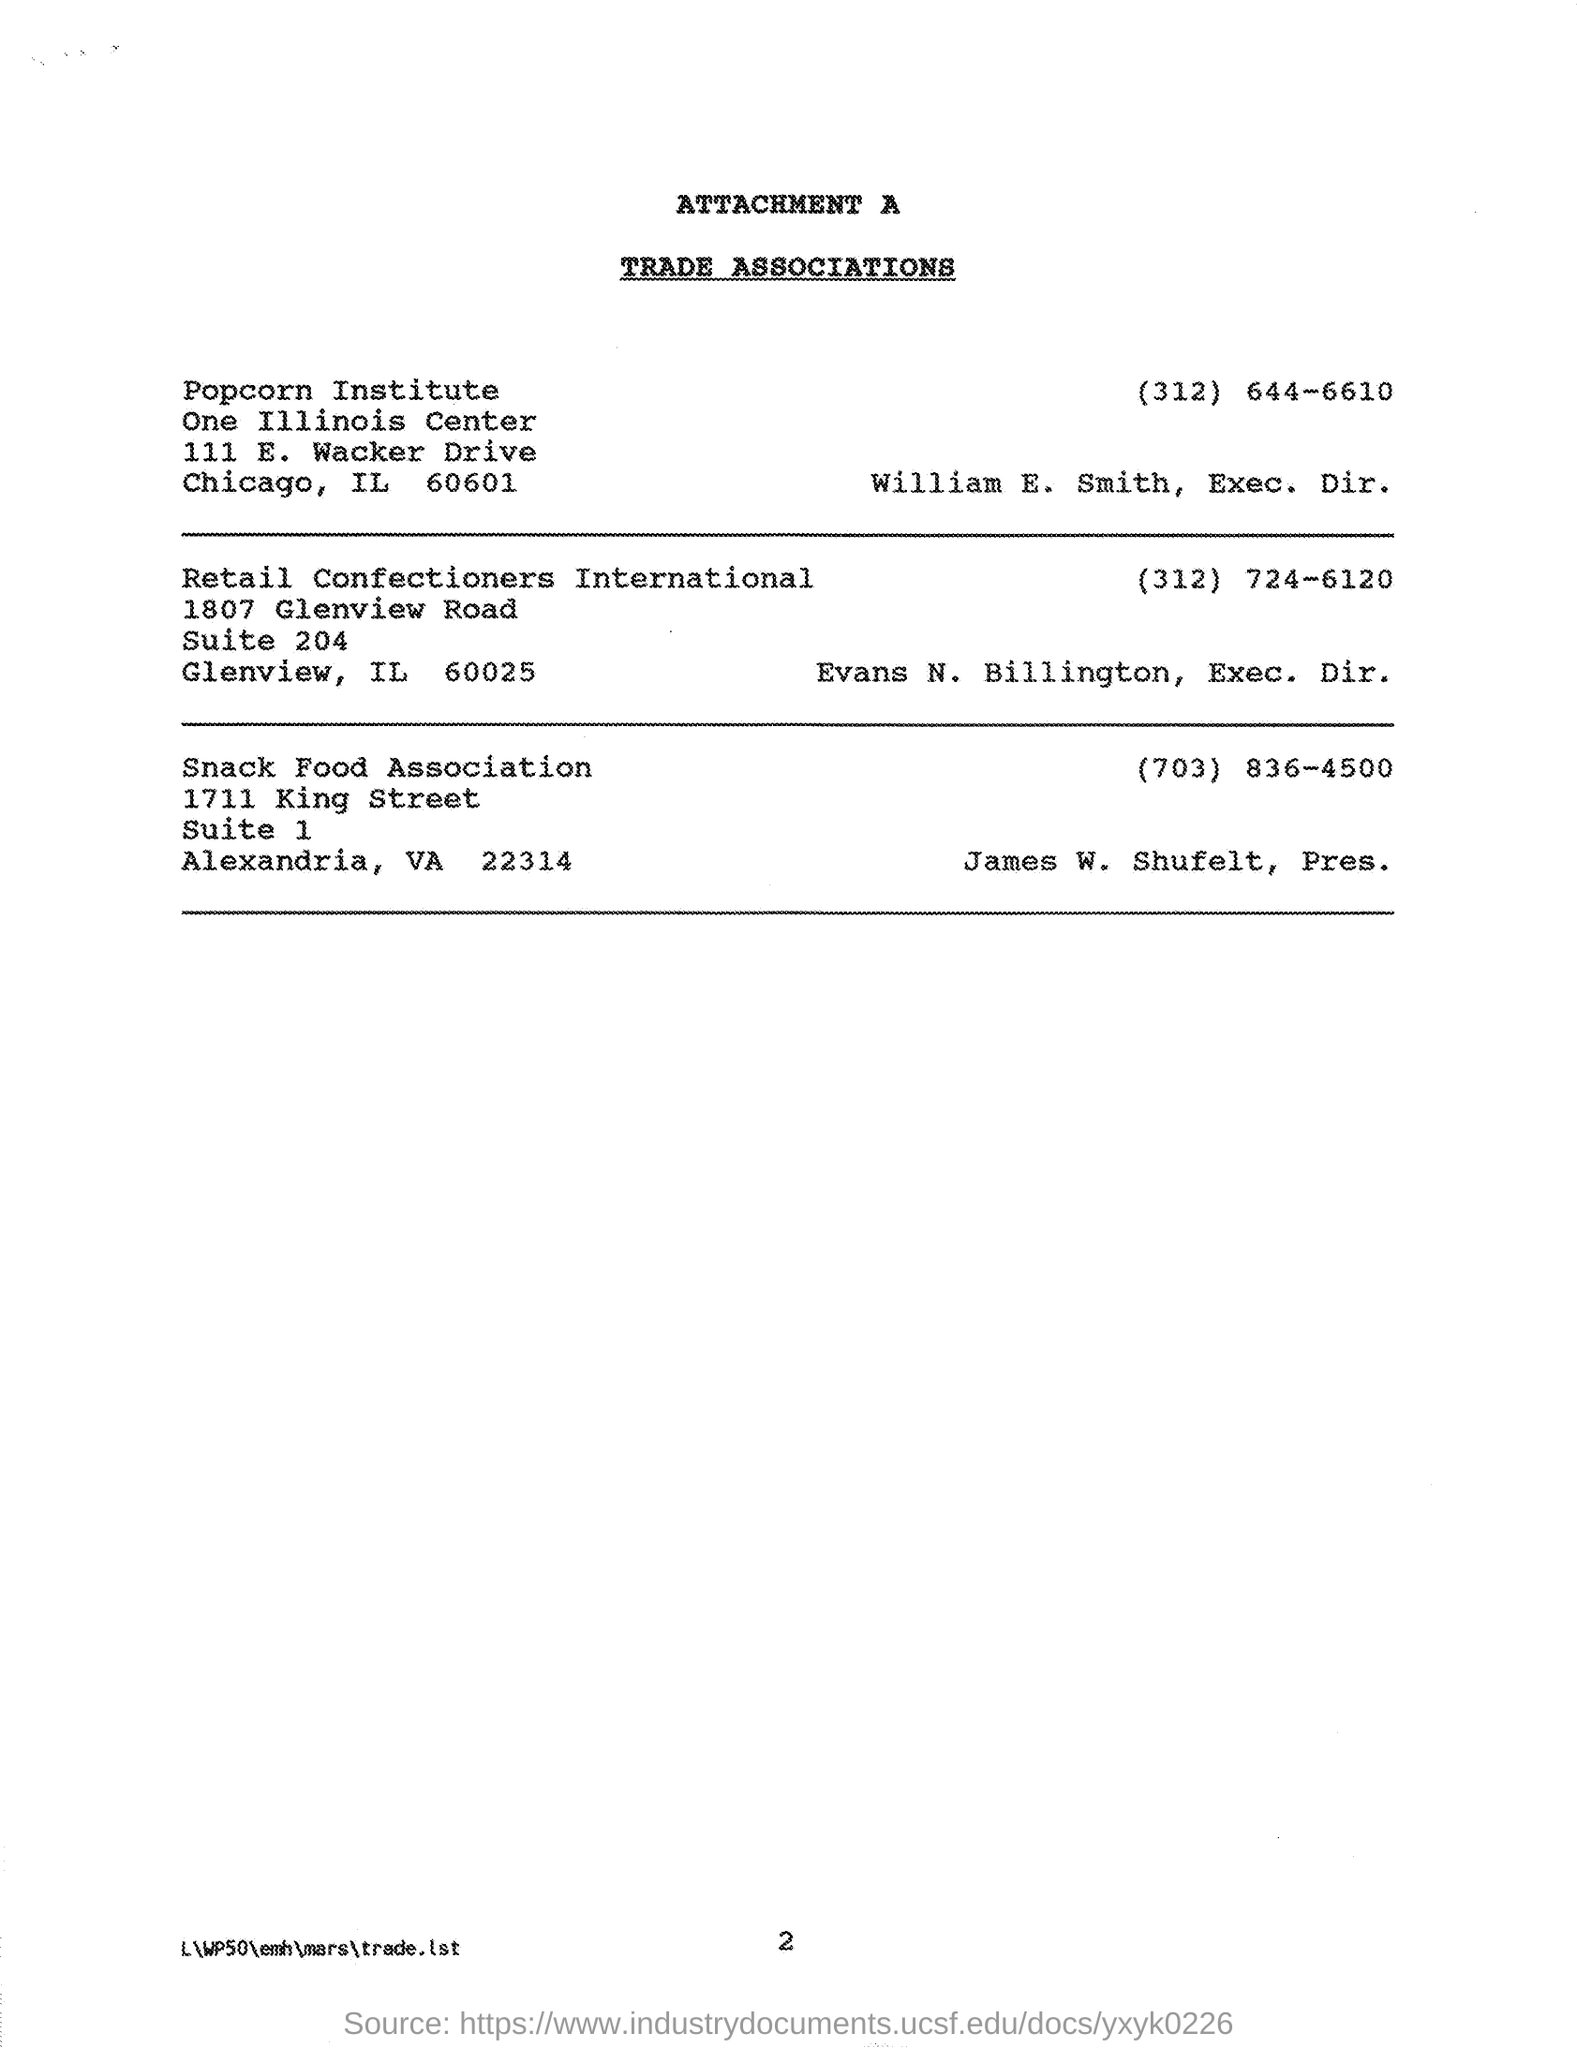Who is the president of snack food association ?
Your response must be concise. James W. Shufelt. Who is the exec. dir. of  retail confectioners international ?
Provide a succinct answer. Evans N. Billington. What is the number given for snack food association ?
Provide a succinct answer. (703) 836-4500. Who is the exec. dir. of popcorn institute ?
Your answer should be compact. William E. Smith. 